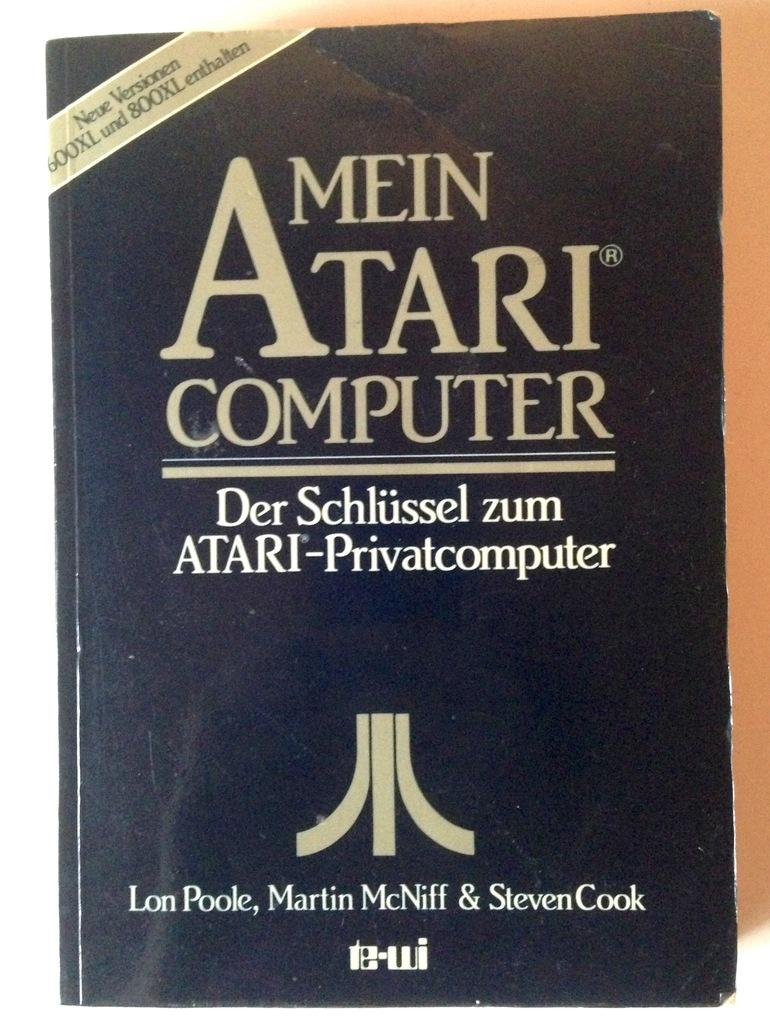<image>
Relay a brief, clear account of the picture shown. A black book is titled Mein Atari Computer. 